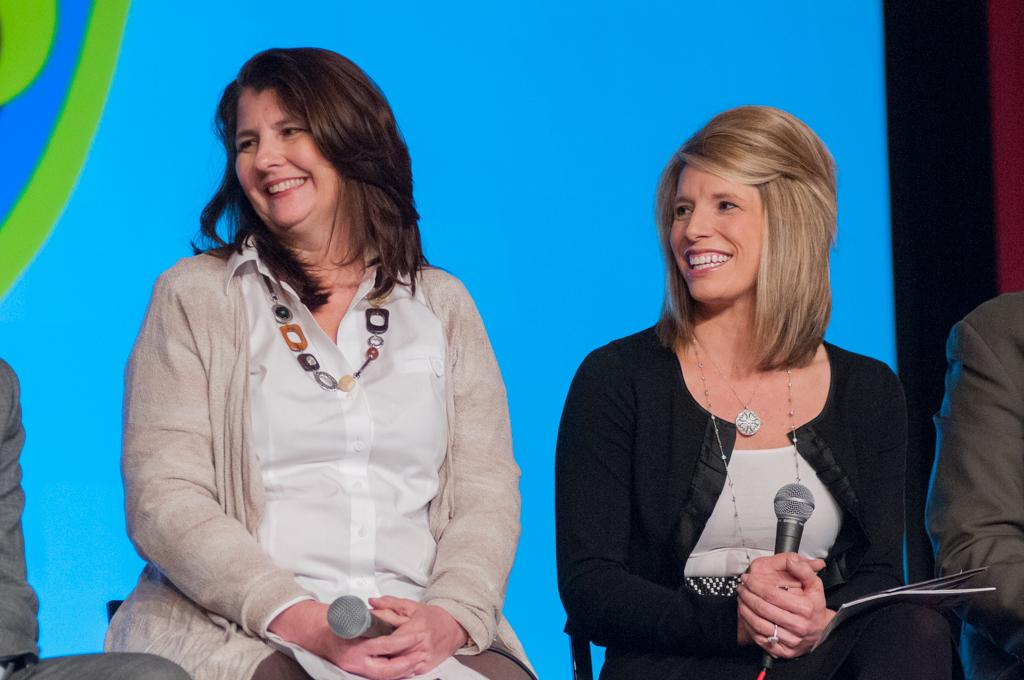How many people are in the image? There are people in the image. Can you describe the position of the people in the image? Two women are seated on chairs in the image. What are the women holding in their hands? The women are holding microphones in their hands. What type of bun can be seen on the head of one of the women in the image? There is no bun visible on the head of either woman in the image. 